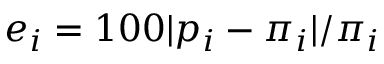<formula> <loc_0><loc_0><loc_500><loc_500>e _ { i } = 1 0 0 | p _ { i } - \pi _ { i } | / \pi _ { i }</formula> 